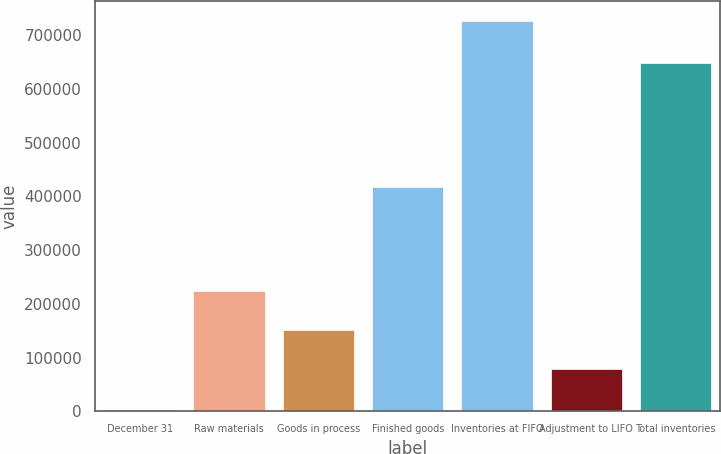Convert chart. <chart><loc_0><loc_0><loc_500><loc_500><bar_chart><fcel>December 31<fcel>Raw materials<fcel>Goods in process<fcel>Finished goods<fcel>Inventories at FIFO<fcel>Adjustment to LIFO<fcel>Total inventories<nl><fcel>2006<fcel>223569<fcel>151037<fcel>418250<fcel>727325<fcel>78505<fcel>648820<nl></chart> 